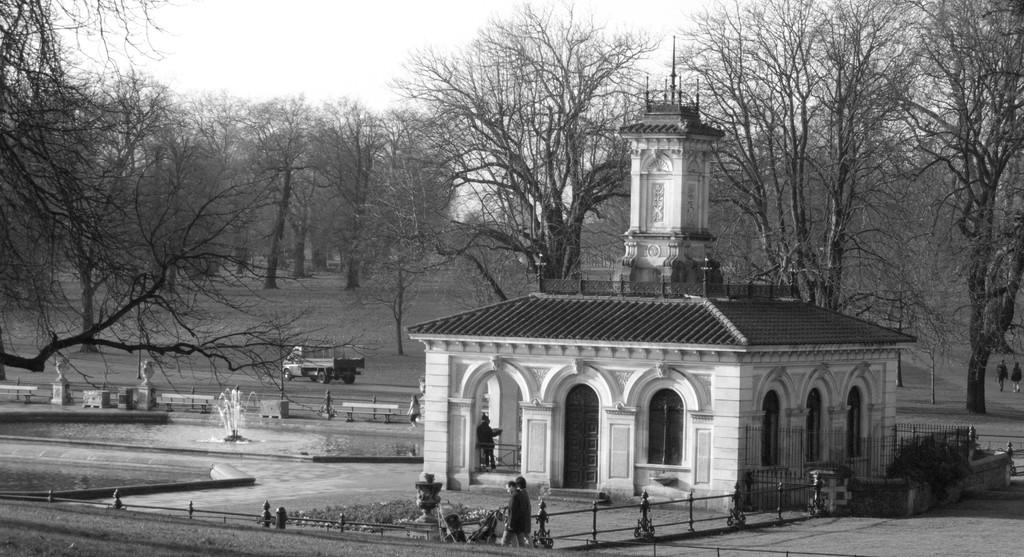What can be seen in the sky in the image? There is sky in the image, but no specific details are provided about the sky. What type of vegetation is present in the image? There are trees and plants in the image. What mode of transportation can be seen in the image? There is a vehicle in the image. What type of infrastructure is visible in the image? There is a road and buildings in the image. What living beings are present in the image? There are people in the image. What additional feature can be found in the image? There is a fountain in the image. How many secretaries are present in the image? There is no mention of secretaries in the image. What type of clothing are the girls wearing in the image? There is no mention of girls in the image. What type of house can be seen in the image? There is no mention of a house in the image. 